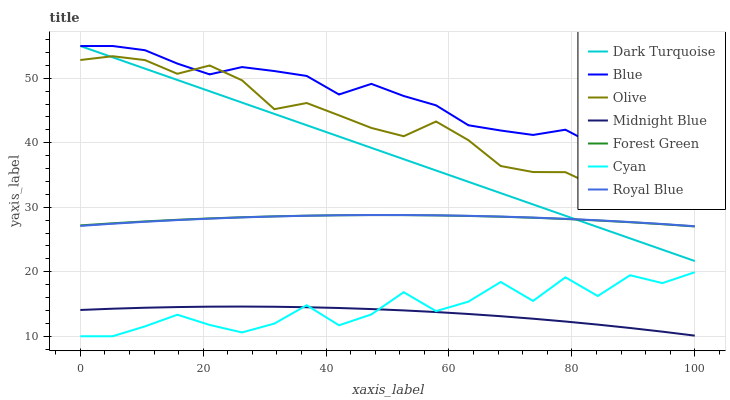Does Dark Turquoise have the minimum area under the curve?
Answer yes or no. No. Does Dark Turquoise have the maximum area under the curve?
Answer yes or no. No. Is Midnight Blue the smoothest?
Answer yes or no. No. Is Midnight Blue the roughest?
Answer yes or no. No. Does Midnight Blue have the lowest value?
Answer yes or no. No. Does Midnight Blue have the highest value?
Answer yes or no. No. Is Midnight Blue less than Olive?
Answer yes or no. Yes. Is Blue greater than Forest Green?
Answer yes or no. Yes. Does Midnight Blue intersect Olive?
Answer yes or no. No. 